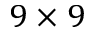Convert formula to latex. <formula><loc_0><loc_0><loc_500><loc_500>9 \times 9</formula> 